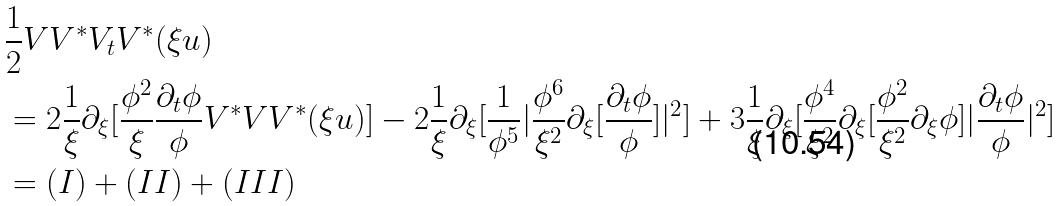<formula> <loc_0><loc_0><loc_500><loc_500>& \frac { 1 } { 2 } V V ^ { \ast } V _ { t } V ^ { \ast } ( \xi u ) \\ & = 2 \frac { 1 } { \xi } \partial _ { \xi } [ \frac { \phi ^ { 2 } } { \xi } \frac { \partial _ { t } \phi } { \phi } V ^ { \ast } V V ^ { \ast } ( \xi u ) ] - 2 \frac { 1 } { \xi } \partial _ { \xi } [ \frac { 1 } { \phi ^ { 5 } } | \frac { \phi ^ { 6 } } { \xi ^ { 2 } } \partial _ { \xi } [ \frac { \partial _ { t } \phi } { \phi } ] | ^ { 2 } ] + 3 \frac { 1 } { \xi } \partial _ { \xi } [ \frac { \phi ^ { 4 } } { \xi ^ { 2 } } \partial _ { \xi } [ \frac { \phi ^ { 2 } } { \xi ^ { 2 } } \partial _ { \xi } \phi ] | \frac { \partial _ { t } \phi } { \phi } | ^ { 2 } ] \\ & = ( I ) + ( I I ) + ( I I I )</formula> 